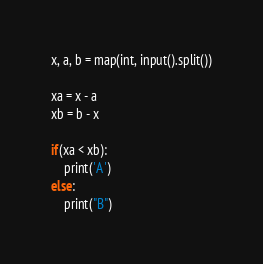Convert code to text. <code><loc_0><loc_0><loc_500><loc_500><_Python_>x, a, b = map(int, input().split())

xa = x - a
xb = b - x

if(xa < xb):
    print('A')
else:
    print("B")</code> 